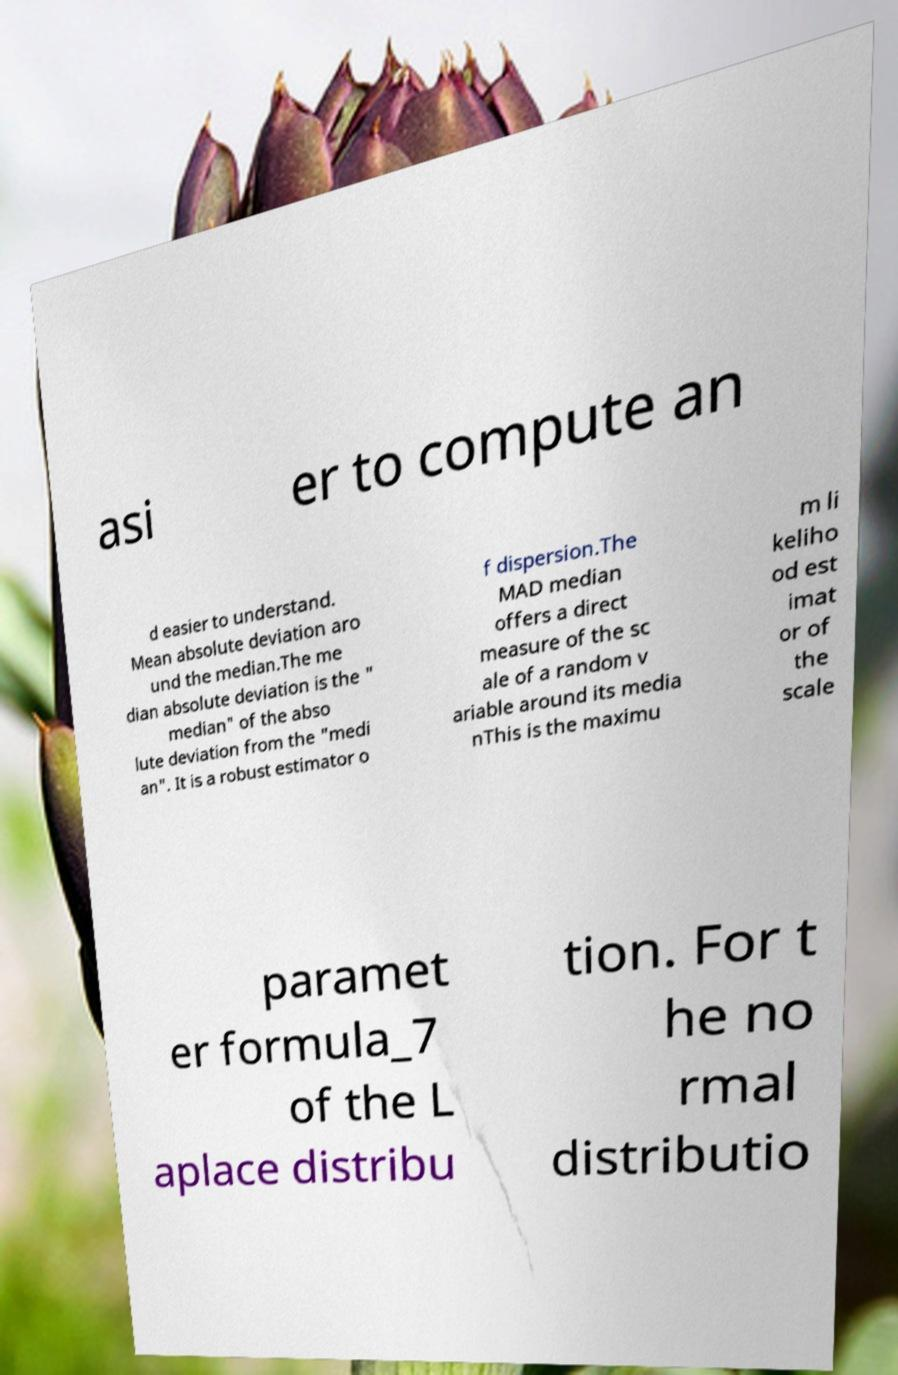What messages or text are displayed in this image? I need them in a readable, typed format. asi er to compute an d easier to understand. Mean absolute deviation aro und the median.The me dian absolute deviation is the " median" of the abso lute deviation from the "medi an". It is a robust estimator o f dispersion.The MAD median offers a direct measure of the sc ale of a random v ariable around its media nThis is the maximu m li keliho od est imat or of the scale paramet er formula_7 of the L aplace distribu tion. For t he no rmal distributio 